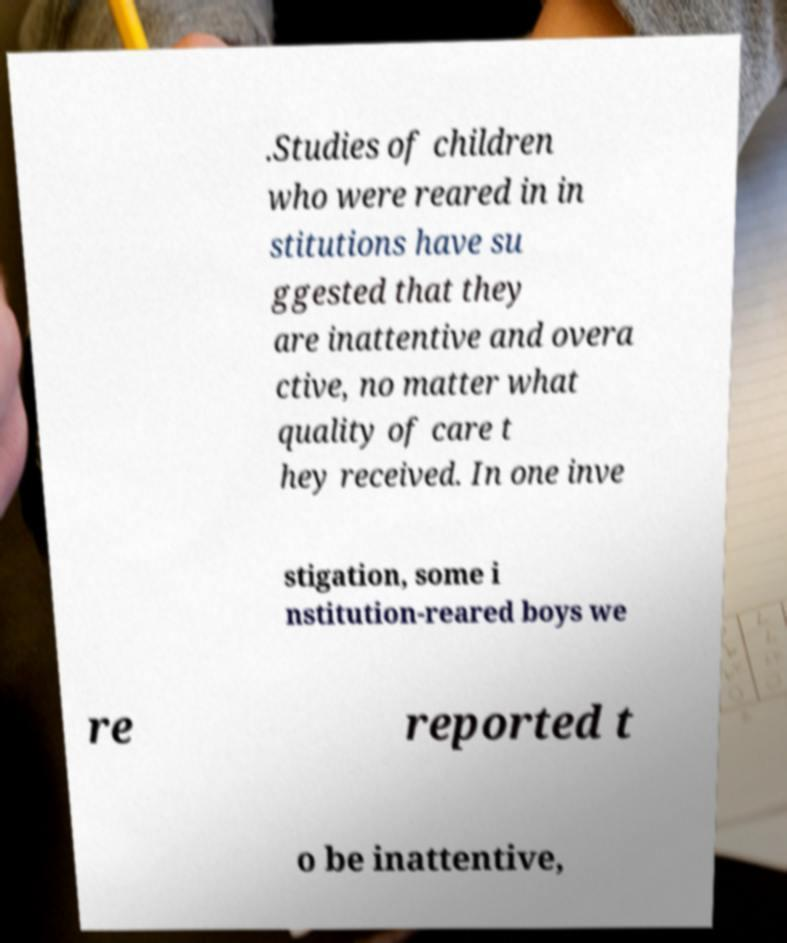For documentation purposes, I need the text within this image transcribed. Could you provide that? .Studies of children who were reared in in stitutions have su ggested that they are inattentive and overa ctive, no matter what quality of care t hey received. In one inve stigation, some i nstitution-reared boys we re reported t o be inattentive, 